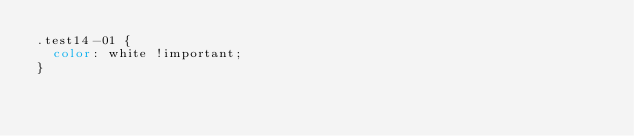<code> <loc_0><loc_0><loc_500><loc_500><_CSS_>.test14-01 {
  color: white !important;
}
</code> 